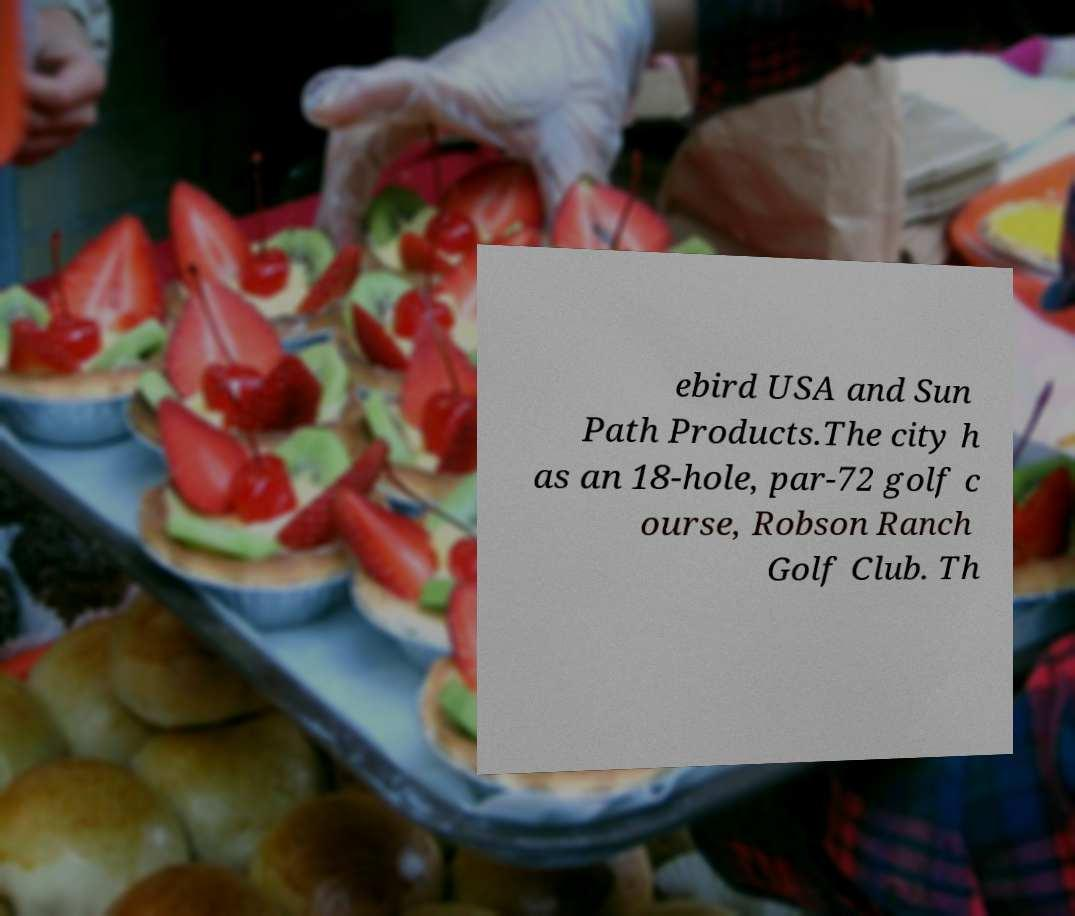There's text embedded in this image that I need extracted. Can you transcribe it verbatim? ebird USA and Sun Path Products.The city h as an 18-hole, par-72 golf c ourse, Robson Ranch Golf Club. Th 